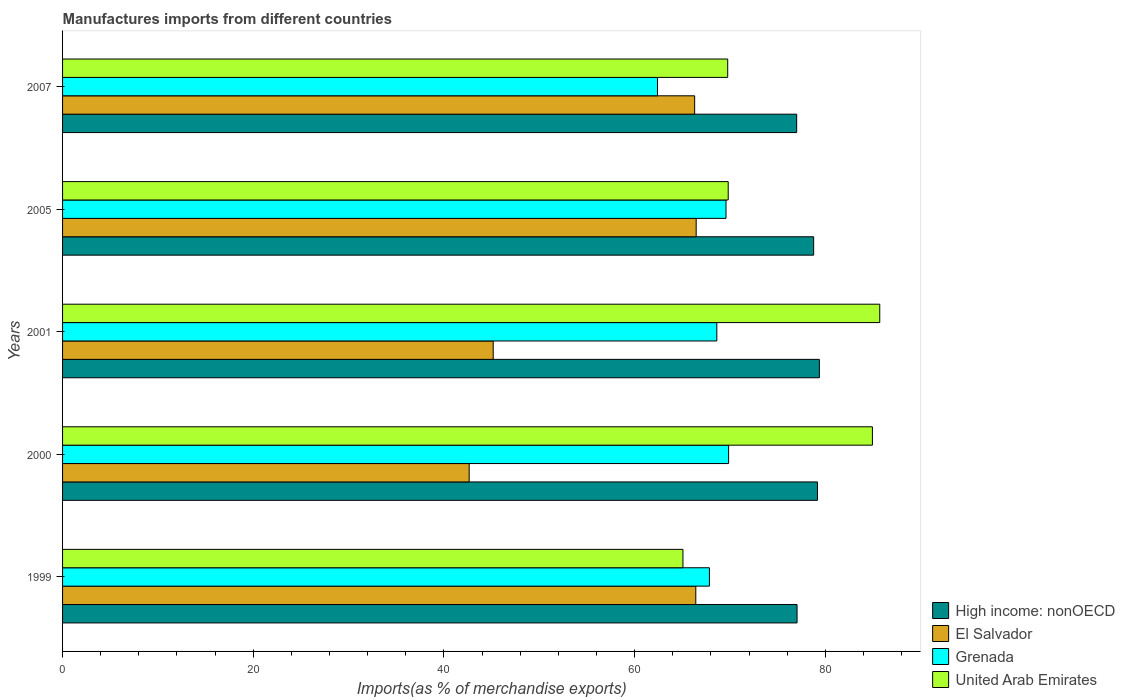How many different coloured bars are there?
Your response must be concise. 4. How many groups of bars are there?
Your answer should be very brief. 5. Are the number of bars per tick equal to the number of legend labels?
Provide a succinct answer. Yes. Are the number of bars on each tick of the Y-axis equal?
Make the answer very short. Yes. How many bars are there on the 5th tick from the top?
Give a very brief answer. 4. What is the label of the 4th group of bars from the top?
Provide a short and direct response. 2000. What is the percentage of imports to different countries in United Arab Emirates in 2001?
Keep it short and to the point. 85.72. Across all years, what is the maximum percentage of imports to different countries in United Arab Emirates?
Give a very brief answer. 85.72. Across all years, what is the minimum percentage of imports to different countries in El Salvador?
Your answer should be compact. 42.65. In which year was the percentage of imports to different countries in High income: nonOECD maximum?
Your answer should be compact. 2001. In which year was the percentage of imports to different countries in United Arab Emirates minimum?
Your answer should be very brief. 1999. What is the total percentage of imports to different countries in High income: nonOECD in the graph?
Your answer should be very brief. 391.39. What is the difference between the percentage of imports to different countries in Grenada in 1999 and that in 2005?
Provide a short and direct response. -1.74. What is the difference between the percentage of imports to different countries in High income: nonOECD in 2005 and the percentage of imports to different countries in El Salvador in 2007?
Give a very brief answer. 12.48. What is the average percentage of imports to different countries in Grenada per year?
Provide a succinct answer. 67.67. In the year 2007, what is the difference between the percentage of imports to different countries in El Salvador and percentage of imports to different countries in High income: nonOECD?
Ensure brevity in your answer.  -10.7. In how many years, is the percentage of imports to different countries in United Arab Emirates greater than 76 %?
Make the answer very short. 2. What is the ratio of the percentage of imports to different countries in Grenada in 1999 to that in 2005?
Offer a terse response. 0.98. Is the percentage of imports to different countries in High income: nonOECD in 2000 less than that in 2005?
Make the answer very short. No. Is the difference between the percentage of imports to different countries in El Salvador in 1999 and 2001 greater than the difference between the percentage of imports to different countries in High income: nonOECD in 1999 and 2001?
Offer a terse response. Yes. What is the difference between the highest and the second highest percentage of imports to different countries in Grenada?
Ensure brevity in your answer.  0.27. What is the difference between the highest and the lowest percentage of imports to different countries in United Arab Emirates?
Provide a short and direct response. 20.64. In how many years, is the percentage of imports to different countries in United Arab Emirates greater than the average percentage of imports to different countries in United Arab Emirates taken over all years?
Provide a succinct answer. 2. Is the sum of the percentage of imports to different countries in Grenada in 2000 and 2001 greater than the maximum percentage of imports to different countries in High income: nonOECD across all years?
Ensure brevity in your answer.  Yes. What does the 3rd bar from the top in 1999 represents?
Keep it short and to the point. El Salvador. What does the 2nd bar from the bottom in 2000 represents?
Give a very brief answer. El Salvador. How many bars are there?
Your answer should be very brief. 20. Are all the bars in the graph horizontal?
Provide a succinct answer. Yes. Does the graph contain any zero values?
Ensure brevity in your answer.  No. Does the graph contain grids?
Give a very brief answer. No. Where does the legend appear in the graph?
Provide a succinct answer. Bottom right. How many legend labels are there?
Provide a short and direct response. 4. What is the title of the graph?
Provide a succinct answer. Manufactures imports from different countries. Does "Costa Rica" appear as one of the legend labels in the graph?
Keep it short and to the point. No. What is the label or title of the X-axis?
Your answer should be very brief. Imports(as % of merchandise exports). What is the label or title of the Y-axis?
Offer a terse response. Years. What is the Imports(as % of merchandise exports) of High income: nonOECD in 1999?
Offer a very short reply. 77.04. What is the Imports(as % of merchandise exports) in El Salvador in 1999?
Ensure brevity in your answer.  66.42. What is the Imports(as % of merchandise exports) in Grenada in 1999?
Give a very brief answer. 67.85. What is the Imports(as % of merchandise exports) in United Arab Emirates in 1999?
Your answer should be compact. 65.07. What is the Imports(as % of merchandise exports) of High income: nonOECD in 2000?
Offer a very short reply. 79.18. What is the Imports(as % of merchandise exports) in El Salvador in 2000?
Provide a short and direct response. 42.65. What is the Imports(as % of merchandise exports) of Grenada in 2000?
Offer a very short reply. 69.86. What is the Imports(as % of merchandise exports) in United Arab Emirates in 2000?
Provide a short and direct response. 84.94. What is the Imports(as % of merchandise exports) of High income: nonOECD in 2001?
Offer a very short reply. 79.38. What is the Imports(as % of merchandise exports) in El Salvador in 2001?
Provide a short and direct response. 45.17. What is the Imports(as % of merchandise exports) of Grenada in 2001?
Your answer should be compact. 68.62. What is the Imports(as % of merchandise exports) in United Arab Emirates in 2001?
Offer a very short reply. 85.72. What is the Imports(as % of merchandise exports) of High income: nonOECD in 2005?
Provide a short and direct response. 78.78. What is the Imports(as % of merchandise exports) in El Salvador in 2005?
Ensure brevity in your answer.  66.46. What is the Imports(as % of merchandise exports) of Grenada in 2005?
Your answer should be very brief. 69.59. What is the Imports(as % of merchandise exports) of United Arab Emirates in 2005?
Provide a short and direct response. 69.82. What is the Imports(as % of merchandise exports) in High income: nonOECD in 2007?
Your answer should be compact. 77. What is the Imports(as % of merchandise exports) of El Salvador in 2007?
Your answer should be very brief. 66.3. What is the Imports(as % of merchandise exports) in Grenada in 2007?
Provide a succinct answer. 62.4. What is the Imports(as % of merchandise exports) in United Arab Emirates in 2007?
Your response must be concise. 69.77. Across all years, what is the maximum Imports(as % of merchandise exports) in High income: nonOECD?
Provide a short and direct response. 79.38. Across all years, what is the maximum Imports(as % of merchandise exports) in El Salvador?
Make the answer very short. 66.46. Across all years, what is the maximum Imports(as % of merchandise exports) of Grenada?
Your answer should be compact. 69.86. Across all years, what is the maximum Imports(as % of merchandise exports) in United Arab Emirates?
Your answer should be very brief. 85.72. Across all years, what is the minimum Imports(as % of merchandise exports) in High income: nonOECD?
Ensure brevity in your answer.  77. Across all years, what is the minimum Imports(as % of merchandise exports) of El Salvador?
Ensure brevity in your answer.  42.65. Across all years, what is the minimum Imports(as % of merchandise exports) of Grenada?
Keep it short and to the point. 62.4. Across all years, what is the minimum Imports(as % of merchandise exports) in United Arab Emirates?
Your response must be concise. 65.07. What is the total Imports(as % of merchandise exports) in High income: nonOECD in the graph?
Your response must be concise. 391.39. What is the total Imports(as % of merchandise exports) in El Salvador in the graph?
Offer a very short reply. 287. What is the total Imports(as % of merchandise exports) in Grenada in the graph?
Offer a very short reply. 338.33. What is the total Imports(as % of merchandise exports) of United Arab Emirates in the graph?
Give a very brief answer. 375.32. What is the difference between the Imports(as % of merchandise exports) of High income: nonOECD in 1999 and that in 2000?
Your response must be concise. -2.14. What is the difference between the Imports(as % of merchandise exports) in El Salvador in 1999 and that in 2000?
Your answer should be compact. 23.77. What is the difference between the Imports(as % of merchandise exports) in Grenada in 1999 and that in 2000?
Keep it short and to the point. -2.01. What is the difference between the Imports(as % of merchandise exports) of United Arab Emirates in 1999 and that in 2000?
Your response must be concise. -19.87. What is the difference between the Imports(as % of merchandise exports) of High income: nonOECD in 1999 and that in 2001?
Provide a short and direct response. -2.34. What is the difference between the Imports(as % of merchandise exports) in El Salvador in 1999 and that in 2001?
Ensure brevity in your answer.  21.25. What is the difference between the Imports(as % of merchandise exports) in Grenada in 1999 and that in 2001?
Give a very brief answer. -0.78. What is the difference between the Imports(as % of merchandise exports) in United Arab Emirates in 1999 and that in 2001?
Offer a terse response. -20.64. What is the difference between the Imports(as % of merchandise exports) of High income: nonOECD in 1999 and that in 2005?
Ensure brevity in your answer.  -1.74. What is the difference between the Imports(as % of merchandise exports) of El Salvador in 1999 and that in 2005?
Offer a terse response. -0.04. What is the difference between the Imports(as % of merchandise exports) in Grenada in 1999 and that in 2005?
Your answer should be very brief. -1.74. What is the difference between the Imports(as % of merchandise exports) in United Arab Emirates in 1999 and that in 2005?
Make the answer very short. -4.75. What is the difference between the Imports(as % of merchandise exports) in High income: nonOECD in 1999 and that in 2007?
Offer a very short reply. 0.04. What is the difference between the Imports(as % of merchandise exports) of El Salvador in 1999 and that in 2007?
Ensure brevity in your answer.  0.12. What is the difference between the Imports(as % of merchandise exports) of Grenada in 1999 and that in 2007?
Your answer should be compact. 5.45. What is the difference between the Imports(as % of merchandise exports) of United Arab Emirates in 1999 and that in 2007?
Keep it short and to the point. -4.69. What is the difference between the Imports(as % of merchandise exports) in High income: nonOECD in 2000 and that in 2001?
Offer a very short reply. -0.2. What is the difference between the Imports(as % of merchandise exports) of El Salvador in 2000 and that in 2001?
Offer a terse response. -2.52. What is the difference between the Imports(as % of merchandise exports) of Grenada in 2000 and that in 2001?
Give a very brief answer. 1.24. What is the difference between the Imports(as % of merchandise exports) in United Arab Emirates in 2000 and that in 2001?
Give a very brief answer. -0.77. What is the difference between the Imports(as % of merchandise exports) in High income: nonOECD in 2000 and that in 2005?
Provide a short and direct response. 0.4. What is the difference between the Imports(as % of merchandise exports) in El Salvador in 2000 and that in 2005?
Ensure brevity in your answer.  -23.81. What is the difference between the Imports(as % of merchandise exports) in Grenada in 2000 and that in 2005?
Provide a succinct answer. 0.27. What is the difference between the Imports(as % of merchandise exports) in United Arab Emirates in 2000 and that in 2005?
Your response must be concise. 15.13. What is the difference between the Imports(as % of merchandise exports) in High income: nonOECD in 2000 and that in 2007?
Offer a terse response. 2.18. What is the difference between the Imports(as % of merchandise exports) in El Salvador in 2000 and that in 2007?
Your answer should be very brief. -23.65. What is the difference between the Imports(as % of merchandise exports) of Grenada in 2000 and that in 2007?
Ensure brevity in your answer.  7.46. What is the difference between the Imports(as % of merchandise exports) in United Arab Emirates in 2000 and that in 2007?
Offer a terse response. 15.18. What is the difference between the Imports(as % of merchandise exports) of High income: nonOECD in 2001 and that in 2005?
Offer a very short reply. 0.6. What is the difference between the Imports(as % of merchandise exports) of El Salvador in 2001 and that in 2005?
Provide a short and direct response. -21.29. What is the difference between the Imports(as % of merchandise exports) in Grenada in 2001 and that in 2005?
Give a very brief answer. -0.96. What is the difference between the Imports(as % of merchandise exports) of United Arab Emirates in 2001 and that in 2005?
Ensure brevity in your answer.  15.9. What is the difference between the Imports(as % of merchandise exports) of High income: nonOECD in 2001 and that in 2007?
Provide a succinct answer. 2.38. What is the difference between the Imports(as % of merchandise exports) of El Salvador in 2001 and that in 2007?
Your response must be concise. -21.13. What is the difference between the Imports(as % of merchandise exports) of Grenada in 2001 and that in 2007?
Your response must be concise. 6.22. What is the difference between the Imports(as % of merchandise exports) of United Arab Emirates in 2001 and that in 2007?
Give a very brief answer. 15.95. What is the difference between the Imports(as % of merchandise exports) of High income: nonOECD in 2005 and that in 2007?
Your answer should be very brief. 1.78. What is the difference between the Imports(as % of merchandise exports) in El Salvador in 2005 and that in 2007?
Your answer should be compact. 0.16. What is the difference between the Imports(as % of merchandise exports) of Grenada in 2005 and that in 2007?
Provide a succinct answer. 7.19. What is the difference between the Imports(as % of merchandise exports) of United Arab Emirates in 2005 and that in 2007?
Your answer should be compact. 0.05. What is the difference between the Imports(as % of merchandise exports) of High income: nonOECD in 1999 and the Imports(as % of merchandise exports) of El Salvador in 2000?
Provide a succinct answer. 34.39. What is the difference between the Imports(as % of merchandise exports) of High income: nonOECD in 1999 and the Imports(as % of merchandise exports) of Grenada in 2000?
Ensure brevity in your answer.  7.18. What is the difference between the Imports(as % of merchandise exports) of High income: nonOECD in 1999 and the Imports(as % of merchandise exports) of United Arab Emirates in 2000?
Your answer should be very brief. -7.9. What is the difference between the Imports(as % of merchandise exports) of El Salvador in 1999 and the Imports(as % of merchandise exports) of Grenada in 2000?
Provide a succinct answer. -3.44. What is the difference between the Imports(as % of merchandise exports) of El Salvador in 1999 and the Imports(as % of merchandise exports) of United Arab Emirates in 2000?
Your answer should be compact. -18.53. What is the difference between the Imports(as % of merchandise exports) of Grenada in 1999 and the Imports(as % of merchandise exports) of United Arab Emirates in 2000?
Offer a terse response. -17.1. What is the difference between the Imports(as % of merchandise exports) of High income: nonOECD in 1999 and the Imports(as % of merchandise exports) of El Salvador in 2001?
Give a very brief answer. 31.87. What is the difference between the Imports(as % of merchandise exports) in High income: nonOECD in 1999 and the Imports(as % of merchandise exports) in Grenada in 2001?
Ensure brevity in your answer.  8.42. What is the difference between the Imports(as % of merchandise exports) in High income: nonOECD in 1999 and the Imports(as % of merchandise exports) in United Arab Emirates in 2001?
Your answer should be compact. -8.67. What is the difference between the Imports(as % of merchandise exports) in El Salvador in 1999 and the Imports(as % of merchandise exports) in Grenada in 2001?
Offer a terse response. -2.21. What is the difference between the Imports(as % of merchandise exports) in El Salvador in 1999 and the Imports(as % of merchandise exports) in United Arab Emirates in 2001?
Provide a succinct answer. -19.3. What is the difference between the Imports(as % of merchandise exports) of Grenada in 1999 and the Imports(as % of merchandise exports) of United Arab Emirates in 2001?
Offer a very short reply. -17.87. What is the difference between the Imports(as % of merchandise exports) in High income: nonOECD in 1999 and the Imports(as % of merchandise exports) in El Salvador in 2005?
Your answer should be compact. 10.58. What is the difference between the Imports(as % of merchandise exports) of High income: nonOECD in 1999 and the Imports(as % of merchandise exports) of Grenada in 2005?
Your response must be concise. 7.45. What is the difference between the Imports(as % of merchandise exports) of High income: nonOECD in 1999 and the Imports(as % of merchandise exports) of United Arab Emirates in 2005?
Keep it short and to the point. 7.22. What is the difference between the Imports(as % of merchandise exports) in El Salvador in 1999 and the Imports(as % of merchandise exports) in Grenada in 2005?
Provide a succinct answer. -3.17. What is the difference between the Imports(as % of merchandise exports) in El Salvador in 1999 and the Imports(as % of merchandise exports) in United Arab Emirates in 2005?
Your response must be concise. -3.4. What is the difference between the Imports(as % of merchandise exports) in Grenada in 1999 and the Imports(as % of merchandise exports) in United Arab Emirates in 2005?
Provide a succinct answer. -1.97. What is the difference between the Imports(as % of merchandise exports) in High income: nonOECD in 1999 and the Imports(as % of merchandise exports) in El Salvador in 2007?
Your answer should be very brief. 10.74. What is the difference between the Imports(as % of merchandise exports) in High income: nonOECD in 1999 and the Imports(as % of merchandise exports) in Grenada in 2007?
Your answer should be very brief. 14.64. What is the difference between the Imports(as % of merchandise exports) of High income: nonOECD in 1999 and the Imports(as % of merchandise exports) of United Arab Emirates in 2007?
Provide a short and direct response. 7.28. What is the difference between the Imports(as % of merchandise exports) of El Salvador in 1999 and the Imports(as % of merchandise exports) of Grenada in 2007?
Keep it short and to the point. 4.02. What is the difference between the Imports(as % of merchandise exports) of El Salvador in 1999 and the Imports(as % of merchandise exports) of United Arab Emirates in 2007?
Provide a succinct answer. -3.35. What is the difference between the Imports(as % of merchandise exports) of Grenada in 1999 and the Imports(as % of merchandise exports) of United Arab Emirates in 2007?
Keep it short and to the point. -1.92. What is the difference between the Imports(as % of merchandise exports) of High income: nonOECD in 2000 and the Imports(as % of merchandise exports) of El Salvador in 2001?
Give a very brief answer. 34.01. What is the difference between the Imports(as % of merchandise exports) of High income: nonOECD in 2000 and the Imports(as % of merchandise exports) of Grenada in 2001?
Make the answer very short. 10.56. What is the difference between the Imports(as % of merchandise exports) in High income: nonOECD in 2000 and the Imports(as % of merchandise exports) in United Arab Emirates in 2001?
Your answer should be very brief. -6.53. What is the difference between the Imports(as % of merchandise exports) in El Salvador in 2000 and the Imports(as % of merchandise exports) in Grenada in 2001?
Ensure brevity in your answer.  -25.98. What is the difference between the Imports(as % of merchandise exports) of El Salvador in 2000 and the Imports(as % of merchandise exports) of United Arab Emirates in 2001?
Provide a short and direct response. -43.07. What is the difference between the Imports(as % of merchandise exports) of Grenada in 2000 and the Imports(as % of merchandise exports) of United Arab Emirates in 2001?
Your answer should be compact. -15.85. What is the difference between the Imports(as % of merchandise exports) in High income: nonOECD in 2000 and the Imports(as % of merchandise exports) in El Salvador in 2005?
Your answer should be compact. 12.72. What is the difference between the Imports(as % of merchandise exports) in High income: nonOECD in 2000 and the Imports(as % of merchandise exports) in Grenada in 2005?
Your answer should be compact. 9.59. What is the difference between the Imports(as % of merchandise exports) of High income: nonOECD in 2000 and the Imports(as % of merchandise exports) of United Arab Emirates in 2005?
Provide a short and direct response. 9.36. What is the difference between the Imports(as % of merchandise exports) of El Salvador in 2000 and the Imports(as % of merchandise exports) of Grenada in 2005?
Provide a succinct answer. -26.94. What is the difference between the Imports(as % of merchandise exports) in El Salvador in 2000 and the Imports(as % of merchandise exports) in United Arab Emirates in 2005?
Ensure brevity in your answer.  -27.17. What is the difference between the Imports(as % of merchandise exports) of Grenada in 2000 and the Imports(as % of merchandise exports) of United Arab Emirates in 2005?
Give a very brief answer. 0.04. What is the difference between the Imports(as % of merchandise exports) in High income: nonOECD in 2000 and the Imports(as % of merchandise exports) in El Salvador in 2007?
Ensure brevity in your answer.  12.88. What is the difference between the Imports(as % of merchandise exports) of High income: nonOECD in 2000 and the Imports(as % of merchandise exports) of Grenada in 2007?
Your response must be concise. 16.78. What is the difference between the Imports(as % of merchandise exports) of High income: nonOECD in 2000 and the Imports(as % of merchandise exports) of United Arab Emirates in 2007?
Your answer should be very brief. 9.41. What is the difference between the Imports(as % of merchandise exports) in El Salvador in 2000 and the Imports(as % of merchandise exports) in Grenada in 2007?
Give a very brief answer. -19.75. What is the difference between the Imports(as % of merchandise exports) of El Salvador in 2000 and the Imports(as % of merchandise exports) of United Arab Emirates in 2007?
Your response must be concise. -27.12. What is the difference between the Imports(as % of merchandise exports) in Grenada in 2000 and the Imports(as % of merchandise exports) in United Arab Emirates in 2007?
Give a very brief answer. 0.1. What is the difference between the Imports(as % of merchandise exports) in High income: nonOECD in 2001 and the Imports(as % of merchandise exports) in El Salvador in 2005?
Make the answer very short. 12.92. What is the difference between the Imports(as % of merchandise exports) of High income: nonOECD in 2001 and the Imports(as % of merchandise exports) of Grenada in 2005?
Ensure brevity in your answer.  9.79. What is the difference between the Imports(as % of merchandise exports) of High income: nonOECD in 2001 and the Imports(as % of merchandise exports) of United Arab Emirates in 2005?
Ensure brevity in your answer.  9.56. What is the difference between the Imports(as % of merchandise exports) in El Salvador in 2001 and the Imports(as % of merchandise exports) in Grenada in 2005?
Give a very brief answer. -24.42. What is the difference between the Imports(as % of merchandise exports) of El Salvador in 2001 and the Imports(as % of merchandise exports) of United Arab Emirates in 2005?
Ensure brevity in your answer.  -24.65. What is the difference between the Imports(as % of merchandise exports) of Grenada in 2001 and the Imports(as % of merchandise exports) of United Arab Emirates in 2005?
Your answer should be very brief. -1.19. What is the difference between the Imports(as % of merchandise exports) of High income: nonOECD in 2001 and the Imports(as % of merchandise exports) of El Salvador in 2007?
Your answer should be compact. 13.08. What is the difference between the Imports(as % of merchandise exports) in High income: nonOECD in 2001 and the Imports(as % of merchandise exports) in Grenada in 2007?
Provide a succinct answer. 16.98. What is the difference between the Imports(as % of merchandise exports) of High income: nonOECD in 2001 and the Imports(as % of merchandise exports) of United Arab Emirates in 2007?
Ensure brevity in your answer.  9.62. What is the difference between the Imports(as % of merchandise exports) in El Salvador in 2001 and the Imports(as % of merchandise exports) in Grenada in 2007?
Your response must be concise. -17.23. What is the difference between the Imports(as % of merchandise exports) in El Salvador in 2001 and the Imports(as % of merchandise exports) in United Arab Emirates in 2007?
Offer a terse response. -24.6. What is the difference between the Imports(as % of merchandise exports) of Grenada in 2001 and the Imports(as % of merchandise exports) of United Arab Emirates in 2007?
Offer a very short reply. -1.14. What is the difference between the Imports(as % of merchandise exports) in High income: nonOECD in 2005 and the Imports(as % of merchandise exports) in El Salvador in 2007?
Offer a terse response. 12.48. What is the difference between the Imports(as % of merchandise exports) of High income: nonOECD in 2005 and the Imports(as % of merchandise exports) of Grenada in 2007?
Keep it short and to the point. 16.38. What is the difference between the Imports(as % of merchandise exports) in High income: nonOECD in 2005 and the Imports(as % of merchandise exports) in United Arab Emirates in 2007?
Your answer should be compact. 9.02. What is the difference between the Imports(as % of merchandise exports) of El Salvador in 2005 and the Imports(as % of merchandise exports) of Grenada in 2007?
Keep it short and to the point. 4.06. What is the difference between the Imports(as % of merchandise exports) of El Salvador in 2005 and the Imports(as % of merchandise exports) of United Arab Emirates in 2007?
Offer a very short reply. -3.31. What is the difference between the Imports(as % of merchandise exports) in Grenada in 2005 and the Imports(as % of merchandise exports) in United Arab Emirates in 2007?
Give a very brief answer. -0.18. What is the average Imports(as % of merchandise exports) of High income: nonOECD per year?
Your answer should be very brief. 78.28. What is the average Imports(as % of merchandise exports) of El Salvador per year?
Your response must be concise. 57.4. What is the average Imports(as % of merchandise exports) in Grenada per year?
Offer a very short reply. 67.67. What is the average Imports(as % of merchandise exports) in United Arab Emirates per year?
Your answer should be compact. 75.06. In the year 1999, what is the difference between the Imports(as % of merchandise exports) in High income: nonOECD and Imports(as % of merchandise exports) in El Salvador?
Provide a short and direct response. 10.62. In the year 1999, what is the difference between the Imports(as % of merchandise exports) of High income: nonOECD and Imports(as % of merchandise exports) of Grenada?
Provide a succinct answer. 9.19. In the year 1999, what is the difference between the Imports(as % of merchandise exports) of High income: nonOECD and Imports(as % of merchandise exports) of United Arab Emirates?
Keep it short and to the point. 11.97. In the year 1999, what is the difference between the Imports(as % of merchandise exports) in El Salvador and Imports(as % of merchandise exports) in Grenada?
Ensure brevity in your answer.  -1.43. In the year 1999, what is the difference between the Imports(as % of merchandise exports) in El Salvador and Imports(as % of merchandise exports) in United Arab Emirates?
Provide a short and direct response. 1.35. In the year 1999, what is the difference between the Imports(as % of merchandise exports) of Grenada and Imports(as % of merchandise exports) of United Arab Emirates?
Give a very brief answer. 2.78. In the year 2000, what is the difference between the Imports(as % of merchandise exports) of High income: nonOECD and Imports(as % of merchandise exports) of El Salvador?
Ensure brevity in your answer.  36.53. In the year 2000, what is the difference between the Imports(as % of merchandise exports) of High income: nonOECD and Imports(as % of merchandise exports) of Grenada?
Your answer should be very brief. 9.32. In the year 2000, what is the difference between the Imports(as % of merchandise exports) in High income: nonOECD and Imports(as % of merchandise exports) in United Arab Emirates?
Provide a succinct answer. -5.76. In the year 2000, what is the difference between the Imports(as % of merchandise exports) of El Salvador and Imports(as % of merchandise exports) of Grenada?
Provide a succinct answer. -27.21. In the year 2000, what is the difference between the Imports(as % of merchandise exports) in El Salvador and Imports(as % of merchandise exports) in United Arab Emirates?
Your answer should be very brief. -42.3. In the year 2000, what is the difference between the Imports(as % of merchandise exports) in Grenada and Imports(as % of merchandise exports) in United Arab Emirates?
Offer a terse response. -15.08. In the year 2001, what is the difference between the Imports(as % of merchandise exports) in High income: nonOECD and Imports(as % of merchandise exports) in El Salvador?
Your response must be concise. 34.21. In the year 2001, what is the difference between the Imports(as % of merchandise exports) of High income: nonOECD and Imports(as % of merchandise exports) of Grenada?
Offer a terse response. 10.76. In the year 2001, what is the difference between the Imports(as % of merchandise exports) in High income: nonOECD and Imports(as % of merchandise exports) in United Arab Emirates?
Provide a short and direct response. -6.33. In the year 2001, what is the difference between the Imports(as % of merchandise exports) in El Salvador and Imports(as % of merchandise exports) in Grenada?
Your answer should be very brief. -23.46. In the year 2001, what is the difference between the Imports(as % of merchandise exports) of El Salvador and Imports(as % of merchandise exports) of United Arab Emirates?
Give a very brief answer. -40.55. In the year 2001, what is the difference between the Imports(as % of merchandise exports) of Grenada and Imports(as % of merchandise exports) of United Arab Emirates?
Provide a short and direct response. -17.09. In the year 2005, what is the difference between the Imports(as % of merchandise exports) of High income: nonOECD and Imports(as % of merchandise exports) of El Salvador?
Make the answer very short. 12.32. In the year 2005, what is the difference between the Imports(as % of merchandise exports) of High income: nonOECD and Imports(as % of merchandise exports) of Grenada?
Your answer should be very brief. 9.19. In the year 2005, what is the difference between the Imports(as % of merchandise exports) in High income: nonOECD and Imports(as % of merchandise exports) in United Arab Emirates?
Provide a short and direct response. 8.96. In the year 2005, what is the difference between the Imports(as % of merchandise exports) in El Salvador and Imports(as % of merchandise exports) in Grenada?
Your answer should be compact. -3.13. In the year 2005, what is the difference between the Imports(as % of merchandise exports) of El Salvador and Imports(as % of merchandise exports) of United Arab Emirates?
Offer a terse response. -3.36. In the year 2005, what is the difference between the Imports(as % of merchandise exports) of Grenada and Imports(as % of merchandise exports) of United Arab Emirates?
Your answer should be very brief. -0.23. In the year 2007, what is the difference between the Imports(as % of merchandise exports) in High income: nonOECD and Imports(as % of merchandise exports) in El Salvador?
Provide a succinct answer. 10.7. In the year 2007, what is the difference between the Imports(as % of merchandise exports) of High income: nonOECD and Imports(as % of merchandise exports) of Grenada?
Provide a succinct answer. 14.6. In the year 2007, what is the difference between the Imports(as % of merchandise exports) in High income: nonOECD and Imports(as % of merchandise exports) in United Arab Emirates?
Ensure brevity in your answer.  7.23. In the year 2007, what is the difference between the Imports(as % of merchandise exports) of El Salvador and Imports(as % of merchandise exports) of Grenada?
Your answer should be very brief. 3.9. In the year 2007, what is the difference between the Imports(as % of merchandise exports) in El Salvador and Imports(as % of merchandise exports) in United Arab Emirates?
Keep it short and to the point. -3.47. In the year 2007, what is the difference between the Imports(as % of merchandise exports) of Grenada and Imports(as % of merchandise exports) of United Arab Emirates?
Your answer should be compact. -7.36. What is the ratio of the Imports(as % of merchandise exports) of El Salvador in 1999 to that in 2000?
Provide a short and direct response. 1.56. What is the ratio of the Imports(as % of merchandise exports) of Grenada in 1999 to that in 2000?
Offer a very short reply. 0.97. What is the ratio of the Imports(as % of merchandise exports) of United Arab Emirates in 1999 to that in 2000?
Provide a short and direct response. 0.77. What is the ratio of the Imports(as % of merchandise exports) of High income: nonOECD in 1999 to that in 2001?
Your answer should be very brief. 0.97. What is the ratio of the Imports(as % of merchandise exports) of El Salvador in 1999 to that in 2001?
Ensure brevity in your answer.  1.47. What is the ratio of the Imports(as % of merchandise exports) of Grenada in 1999 to that in 2001?
Provide a short and direct response. 0.99. What is the ratio of the Imports(as % of merchandise exports) in United Arab Emirates in 1999 to that in 2001?
Make the answer very short. 0.76. What is the ratio of the Imports(as % of merchandise exports) in High income: nonOECD in 1999 to that in 2005?
Offer a terse response. 0.98. What is the ratio of the Imports(as % of merchandise exports) in Grenada in 1999 to that in 2005?
Give a very brief answer. 0.97. What is the ratio of the Imports(as % of merchandise exports) of United Arab Emirates in 1999 to that in 2005?
Your response must be concise. 0.93. What is the ratio of the Imports(as % of merchandise exports) of High income: nonOECD in 1999 to that in 2007?
Your answer should be compact. 1. What is the ratio of the Imports(as % of merchandise exports) of El Salvador in 1999 to that in 2007?
Keep it short and to the point. 1. What is the ratio of the Imports(as % of merchandise exports) of Grenada in 1999 to that in 2007?
Make the answer very short. 1.09. What is the ratio of the Imports(as % of merchandise exports) in United Arab Emirates in 1999 to that in 2007?
Offer a terse response. 0.93. What is the ratio of the Imports(as % of merchandise exports) in El Salvador in 2000 to that in 2001?
Offer a terse response. 0.94. What is the ratio of the Imports(as % of merchandise exports) in Grenada in 2000 to that in 2001?
Give a very brief answer. 1.02. What is the ratio of the Imports(as % of merchandise exports) of El Salvador in 2000 to that in 2005?
Your answer should be compact. 0.64. What is the ratio of the Imports(as % of merchandise exports) of Grenada in 2000 to that in 2005?
Keep it short and to the point. 1. What is the ratio of the Imports(as % of merchandise exports) in United Arab Emirates in 2000 to that in 2005?
Your answer should be very brief. 1.22. What is the ratio of the Imports(as % of merchandise exports) in High income: nonOECD in 2000 to that in 2007?
Offer a terse response. 1.03. What is the ratio of the Imports(as % of merchandise exports) of El Salvador in 2000 to that in 2007?
Your answer should be compact. 0.64. What is the ratio of the Imports(as % of merchandise exports) of Grenada in 2000 to that in 2007?
Your answer should be compact. 1.12. What is the ratio of the Imports(as % of merchandise exports) in United Arab Emirates in 2000 to that in 2007?
Provide a succinct answer. 1.22. What is the ratio of the Imports(as % of merchandise exports) of High income: nonOECD in 2001 to that in 2005?
Offer a very short reply. 1.01. What is the ratio of the Imports(as % of merchandise exports) in El Salvador in 2001 to that in 2005?
Make the answer very short. 0.68. What is the ratio of the Imports(as % of merchandise exports) of Grenada in 2001 to that in 2005?
Your answer should be compact. 0.99. What is the ratio of the Imports(as % of merchandise exports) of United Arab Emirates in 2001 to that in 2005?
Keep it short and to the point. 1.23. What is the ratio of the Imports(as % of merchandise exports) of High income: nonOECD in 2001 to that in 2007?
Your answer should be very brief. 1.03. What is the ratio of the Imports(as % of merchandise exports) of El Salvador in 2001 to that in 2007?
Give a very brief answer. 0.68. What is the ratio of the Imports(as % of merchandise exports) in Grenada in 2001 to that in 2007?
Offer a terse response. 1.1. What is the ratio of the Imports(as % of merchandise exports) of United Arab Emirates in 2001 to that in 2007?
Make the answer very short. 1.23. What is the ratio of the Imports(as % of merchandise exports) of High income: nonOECD in 2005 to that in 2007?
Keep it short and to the point. 1.02. What is the ratio of the Imports(as % of merchandise exports) of El Salvador in 2005 to that in 2007?
Make the answer very short. 1. What is the ratio of the Imports(as % of merchandise exports) in Grenada in 2005 to that in 2007?
Give a very brief answer. 1.12. What is the difference between the highest and the second highest Imports(as % of merchandise exports) in High income: nonOECD?
Keep it short and to the point. 0.2. What is the difference between the highest and the second highest Imports(as % of merchandise exports) in El Salvador?
Make the answer very short. 0.04. What is the difference between the highest and the second highest Imports(as % of merchandise exports) of Grenada?
Offer a terse response. 0.27. What is the difference between the highest and the second highest Imports(as % of merchandise exports) of United Arab Emirates?
Provide a succinct answer. 0.77. What is the difference between the highest and the lowest Imports(as % of merchandise exports) in High income: nonOECD?
Give a very brief answer. 2.38. What is the difference between the highest and the lowest Imports(as % of merchandise exports) in El Salvador?
Provide a succinct answer. 23.81. What is the difference between the highest and the lowest Imports(as % of merchandise exports) in Grenada?
Give a very brief answer. 7.46. What is the difference between the highest and the lowest Imports(as % of merchandise exports) of United Arab Emirates?
Your answer should be compact. 20.64. 